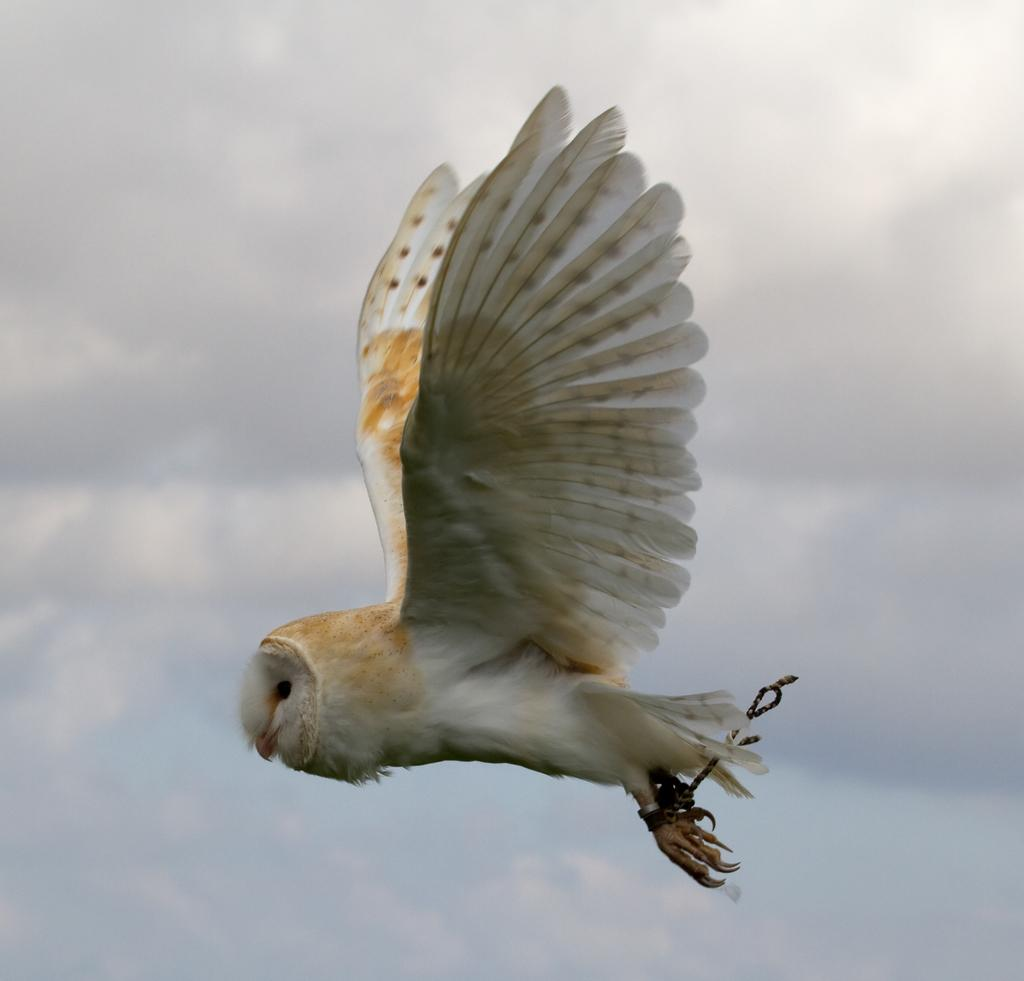What type of animal is in the image? There is a bird in the image. What is the bird doing in the image? The bird is flying in the air. What color is the bird? The bird is white in color. What can be seen in the background of the image? There are clouds in the sky in the background of the image. Reasoning: Let'ing: Let's think step by step in order to produce the conversation. We start by identifying the main subject in the image, which is the bird. Then, we describe the bird's action, which is flying in the air. Next, we mention the bird's color, which is white. Finally, we describe the background of the image, which includes clouds in the sky. Each question is designed to elicit a specific detail about the image that is known from the provided facts. Absurd Question/Answer: What type of feast is the bird attending in the image? There is no feast present in the image; it simply shows a white bird flying in the air. 